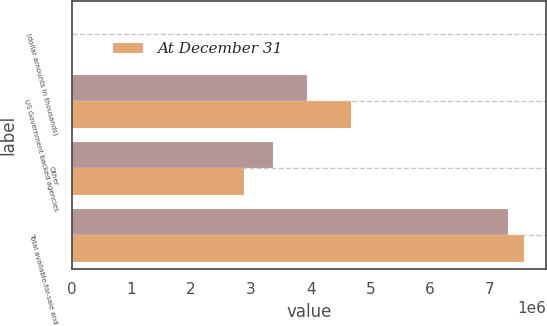Convert chart to OTSL. <chart><loc_0><loc_0><loc_500><loc_500><stacked_bar_chart><ecel><fcel>(dollar amounts in thousands)<fcel>US Government backed agencies<fcel>Other<fcel>Total available-for-sale and<nl><fcel>nan<fcel>2013<fcel>3.93771e+06<fcel>3.37104e+06<fcel>7.30875e+06<nl><fcel>At December 31<fcel>2012<fcel>4.67661e+06<fcel>2.88957e+06<fcel>7.56618e+06<nl></chart> 